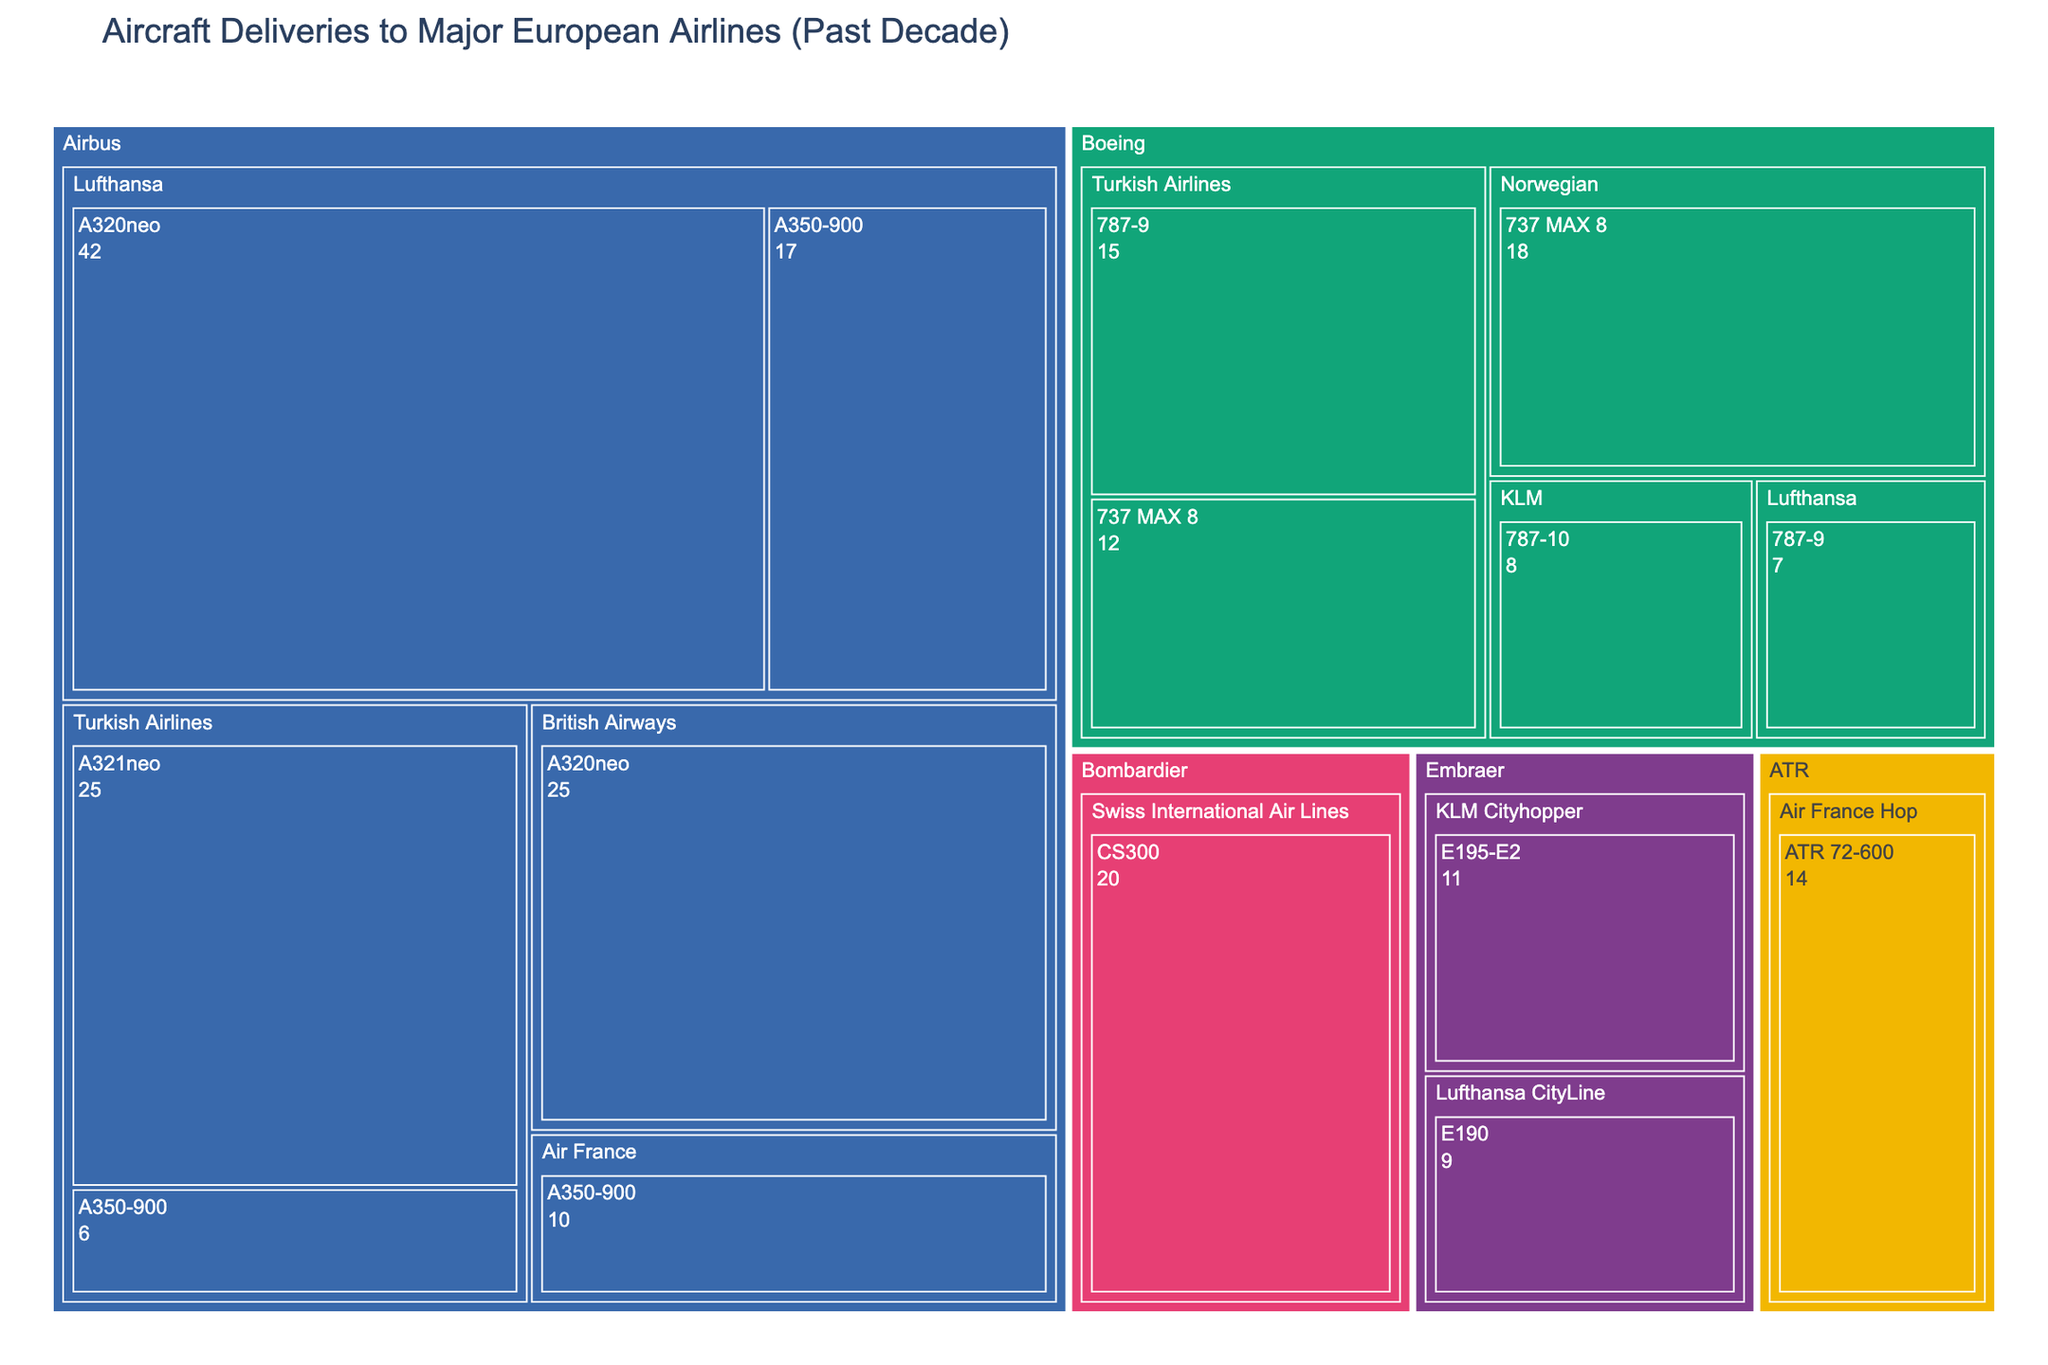What's the title of the treemap? The title of the treemap is displayed at the top of the figure, usually in a larger or bold font.
Answer: Aircraft Deliveries to Major European Airlines (Past Decade) Which airline has received the most Airbus A320neos? Look for the block labeled "A320neo" within the Airbus section and identify the airline associated with the largest block size for this aircraft.
Answer: Lufthansa How many total deliveries has Turkish Airlines received from Boeing? Add the deliveries of the 787-9 and 737 MAX 8 for Turkish Airlines within the Boeing section. 15 (787-9) + 12 (737 MAX 8) = 27.
Answer: 27 Which manufacturer has the largest number of overall deliveries to European airlines? Compare the overall size of each manufacturer's section to determine which is the largest. Airbus section is the most extensive, indicating it has the highest number of deliveries.
Answer: Airbus Compare the deliveries of ATR 72-600 by Air France Hop and E195-E2 by KLM Cityhopper. Which is greater? Check the deliveries numbers shown in the sections for ATR 72-600 and E195-E2 and compare them. ATR 72-600 (14) and E195-E2 (11).
Answer: ATR 72-600 What is the total number of Airbus A350-900 deliveries to all airlines? Add the deliveries of A350-900 for each airline: Turkish Airlines (6) + Lufthansa (17) + Air France (10) = 33.
Answer: 33 Which airline has more overall deliveries, British Airways or Norwegian? Compare the total size of the blocks for British Airways and Norwegian. Total deliveries: British Airways (25 from A320neo), Norwegian (18 from 737 MAX 8).
Answer: British Airways What is the difference in deliveries between Lufthansa and Turkish Airlines for Boeing aircraft? Subtract the Boeing deliveries for Turkish Airlines from Lufthansa's. Lufthansa (7), Turkish Airlines (15+12=27). Difference: 27 - 7 = 20.
Answer: 20 Which Embraer aircraft received the most deliveries by a single airline? Look at the blocks in the Embraer section and identify which one has the highest number of deliveries by any airline. E195-E2 by KLM Cityhopper (11) vs. E190 by Lufthansa CityLine (9).
Answer: E195-E2 Count the number of unique aircraft types delivered to all airlines. Count the distinct aircraft labels across all sections in the treemap. Unique aircraft types: A321neo, A350-900, A320neo, 787-9, 737 MAX 8, 787-10, ATR 72-600, CS300, E195-E2, and E190, making a total of 10.
Answer: 10 